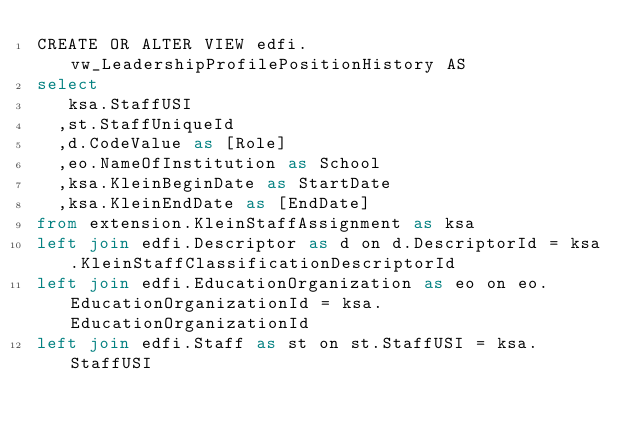Convert code to text. <code><loc_0><loc_0><loc_500><loc_500><_SQL_>CREATE OR ALTER VIEW edfi.vw_LeadershipProfilePositionHistory AS
select
	 ksa.StaffUSI
	,st.StaffUniqueId
	,d.CodeValue as [Role]
	,eo.NameOfInstitution as School
	,ksa.KleinBeginDate as StartDate
	,ksa.KleinEndDate as [EndDate]
from extension.KleinStaffAssignment as ksa
left join edfi.Descriptor as d on d.DescriptorId = ksa.KleinStaffClassificationDescriptorId
left join edfi.EducationOrganization as eo on eo.EducationOrganizationId = ksa.EducationOrganizationId
left join edfi.Staff as st on st.StaffUSI = ksa.StaffUSI</code> 